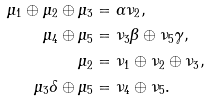<formula> <loc_0><loc_0><loc_500><loc_500>\mu _ { 1 } \oplus \mu _ { 2 } \oplus \mu _ { 3 } & = \alpha \nu _ { 2 } , \\ \mu _ { 4 } \oplus \mu _ { 5 } & = \nu _ { 3 } \beta \oplus \nu _ { 5 } \gamma , \\ \mu _ { 2 } & = \nu _ { 1 } \oplus \nu _ { 2 } \oplus \nu _ { 3 } , \\ \mu _ { 3 } \delta \oplus \mu _ { 5 } & = \nu _ { 4 } \oplus \nu _ { 5 } .</formula> 